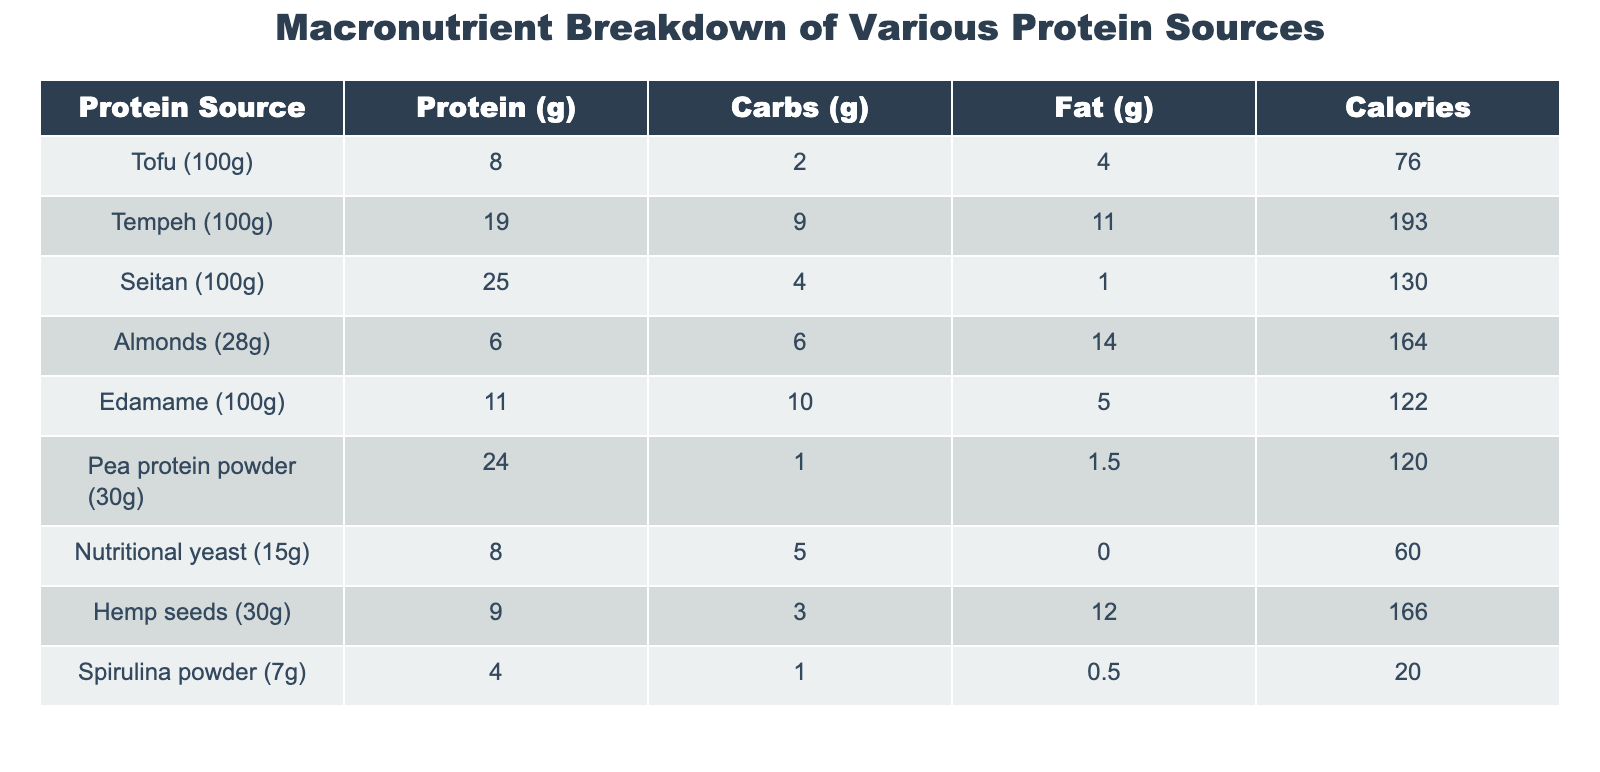What is the protein content in Tempeh? The table shows that Tempeh contains 19 grams of protein per 100 grams.
Answer: 19 grams Which protein source has the highest fat content? By comparing the fat content values for all protein sources, Seitan has the lowest at 1 gram, while Almonds have the highest at 14 grams.
Answer: Almonds What is the total protein content of Tofu and Edamame combined? Tofu has 8 grams and Edamame has 11 grams. Adding these values gives 8 + 11 = 19 grams.
Answer: 19 grams Is the protein content in Pea protein powder higher than in Edamame? Pea protein powder has 24 grams of protein, while Edamame has 11 grams, confirming that Pea protein powder has a higher protein content.
Answer: Yes What is the average amount of carbohydrates per 100 grams for all protein sources? The total carbohydrates from all sources are 2 + 9 + 4 + 6 + 10 + 1 + 5 + 3 + 1 = 41 grams. There are 9 protein sources, so the average is 41 / 9 ≈ 4.56 grams.
Answer: Approximately 4.56 grams Which sources provide the least calories, and how many do they have? Spirulina powder has the lowest calories at 20, followed by Nutritional yeast at 60 calories.
Answer: 20 calories (Spirulina powder) If you were to prioritize protein intake, which three sources would you choose based on the table? The sources with the highest protein content are Seitan (25 grams), Pea protein powder (24 grams), and Tempeh (19 grams).
Answer: Seitan, Pea protein powder, Tempeh How much total fat is present in 100 grams of Tofu and 30 grams of Hemp seeds? Tofu has 4 grams of fat and Hemp seeds have 12 grams of fat. Adding these gives 4 + 12 = 16 grams of fat total.
Answer: 16 grams Does any protein source contain zero grams of fat? The table shows that Spirulina powder has 0.5 grams of fat, meaning no source listed has zero fat content.
Answer: No 